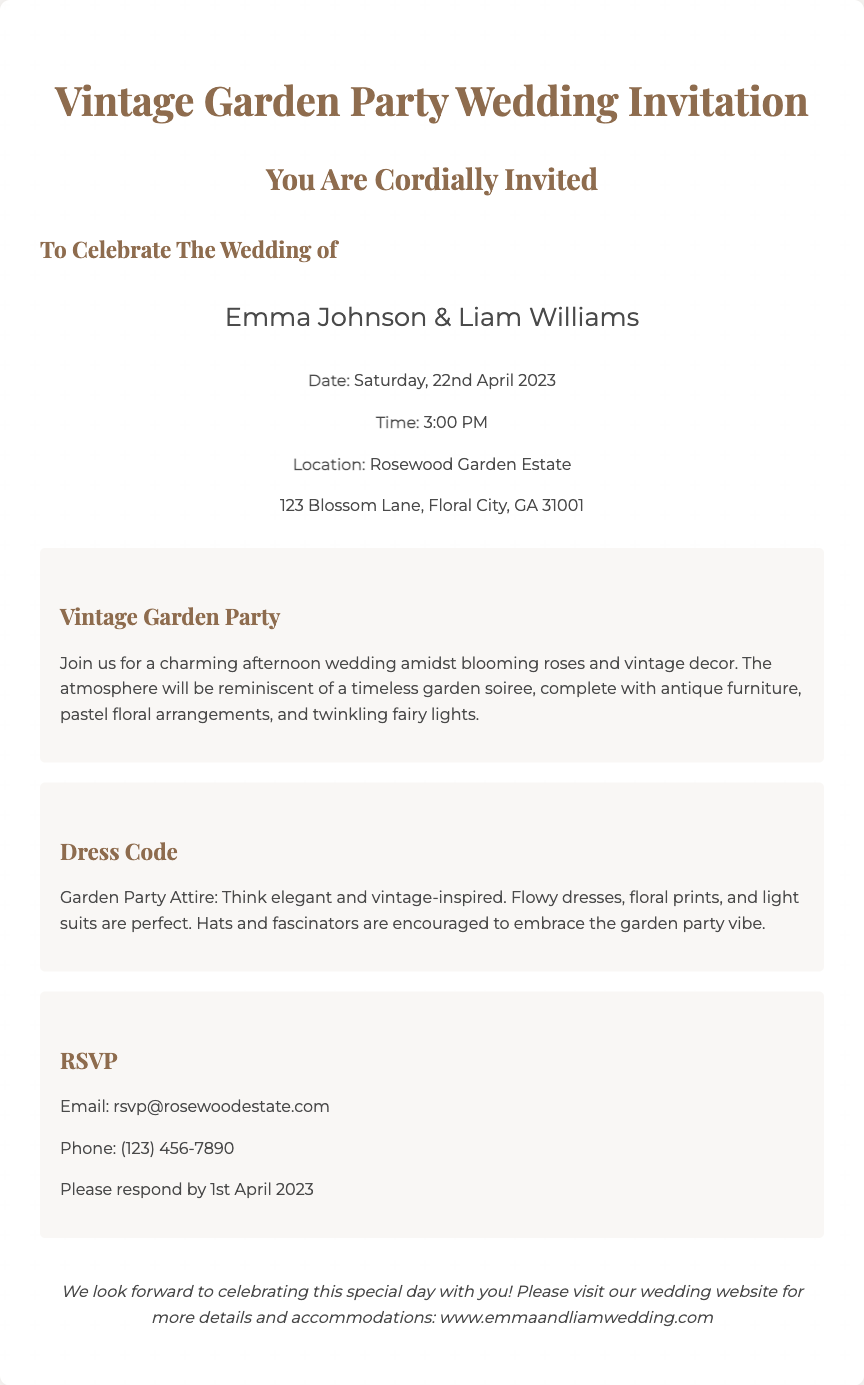What is the name of the couple getting married? The names of the couple are presented prominently in the invitation.
Answer: Emma Johnson & Liam Williams What is the date of the wedding? The document specifies the date of the wedding clearly in the details section.
Answer: Saturday, 22nd April 2023 What time does the wedding start? The time is noted in the details of the invitation.
Answer: 3:00 PM Where is the location of the wedding? The location can be found in the details section of the invitation.
Answer: Rosewood Garden Estate What is the dress code for the event? The dress code is explicitly stated in its own section in the document.
Answer: Garden Party Attire What theme is the wedding based on? The theme is highlighted in a dedicated section of the invitation.
Answer: Vintage Garden Party By what date should guests RSVP? The RSVP deadline is outlined in the RSVP section of the invitation.
Answer: 1st April 2023 What is the contact email for RSVPs? The RSVP contact information is clearly stated in the invitation.
Answer: rsvp@rosewoodestate.com What type of atmosphere is described for the wedding? The overall ambiance is described within the theme section.
Answer: Charming afternoon wedding amidst blooming roses and vintage decor 